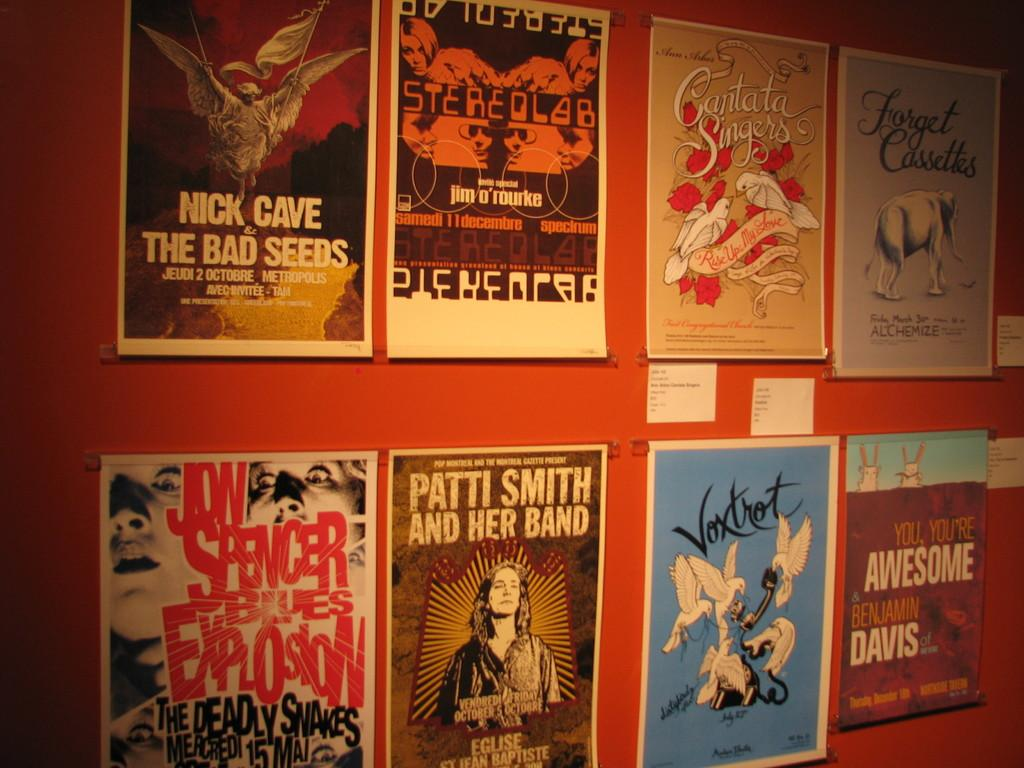What color is the wall in the image? The wall in the image is red. What is attached to the wall? The wall has photos attached to it. What types of subjects are featured in the photos? The photos are of people, animals, birds, and other things. Can you hear the beggar asking for help in the image? There is no beggar present in the image, and therefore no sound can be heard. 